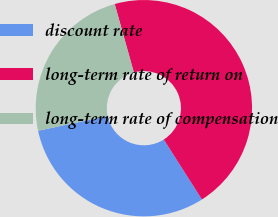<chart> <loc_0><loc_0><loc_500><loc_500><pie_chart><fcel>discount rate<fcel>long-term rate of return on<fcel>long-term rate of compensation<nl><fcel>30.67%<fcel>45.33%<fcel>24.0%<nl></chart> 